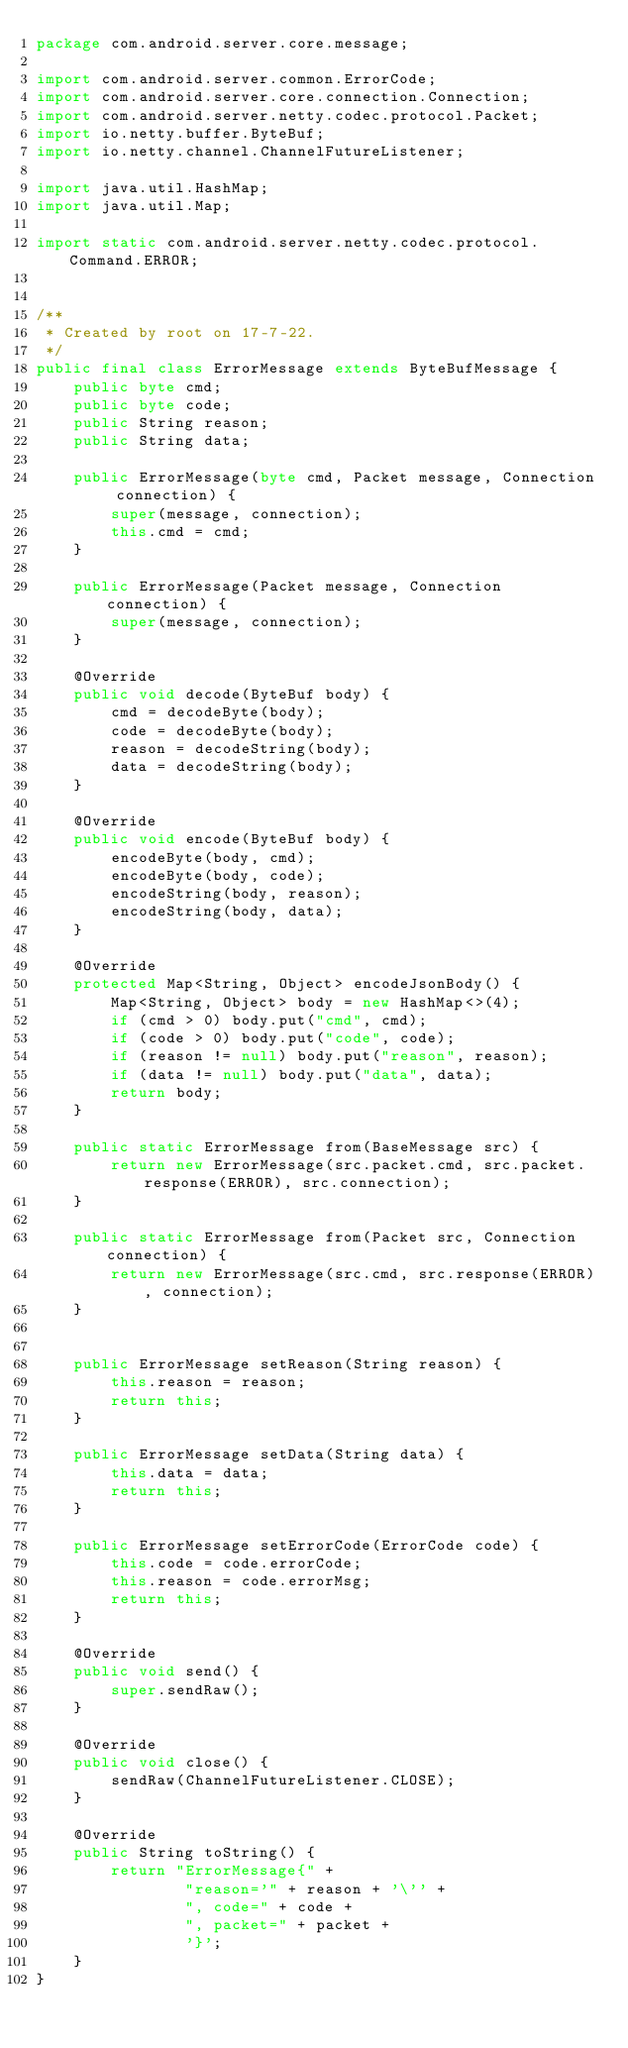<code> <loc_0><loc_0><loc_500><loc_500><_Java_>package com.android.server.core.message;

import com.android.server.common.ErrorCode;
import com.android.server.core.connection.Connection;
import com.android.server.netty.codec.protocol.Packet;
import io.netty.buffer.ByteBuf;
import io.netty.channel.ChannelFutureListener;

import java.util.HashMap;
import java.util.Map;

import static com.android.server.netty.codec.protocol.Command.ERROR;


/**
 * Created by root on 17-7-22.
 */
public final class ErrorMessage extends ByteBufMessage {
    public byte cmd;
    public byte code;
    public String reason;
    public String data;

    public ErrorMessage(byte cmd, Packet message, Connection connection) {
        super(message, connection);
        this.cmd = cmd;
    }

    public ErrorMessage(Packet message, Connection connection) {
        super(message, connection);
    }

    @Override
    public void decode(ByteBuf body) {
        cmd = decodeByte(body);
        code = decodeByte(body);
        reason = decodeString(body);
        data = decodeString(body);
    }

    @Override
    public void encode(ByteBuf body) {
        encodeByte(body, cmd);
        encodeByte(body, code);
        encodeString(body, reason);
        encodeString(body, data);
    }

    @Override
    protected Map<String, Object> encodeJsonBody() {
        Map<String, Object> body = new HashMap<>(4);
        if (cmd > 0) body.put("cmd", cmd);
        if (code > 0) body.put("code", code);
        if (reason != null) body.put("reason", reason);
        if (data != null) body.put("data", data);
        return body;
    }

    public static ErrorMessage from(BaseMessage src) {
        return new ErrorMessage(src.packet.cmd, src.packet.response(ERROR), src.connection);
    }

    public static ErrorMessage from(Packet src, Connection connection) {
        return new ErrorMessage(src.cmd, src.response(ERROR), connection);
    }


    public ErrorMessage setReason(String reason) {
        this.reason = reason;
        return this;
    }

    public ErrorMessage setData(String data) {
        this.data = data;
        return this;
    }

    public ErrorMessage setErrorCode(ErrorCode code) {
        this.code = code.errorCode;
        this.reason = code.errorMsg;
        return this;
    }

    @Override
    public void send() {
        super.sendRaw();
    }

    @Override
    public void close() {
        sendRaw(ChannelFutureListener.CLOSE);
    }

    @Override
    public String toString() {
        return "ErrorMessage{" +
                "reason='" + reason + '\'' +
                ", code=" + code +
                ", packet=" + packet +
                '}';
    }
}
</code> 